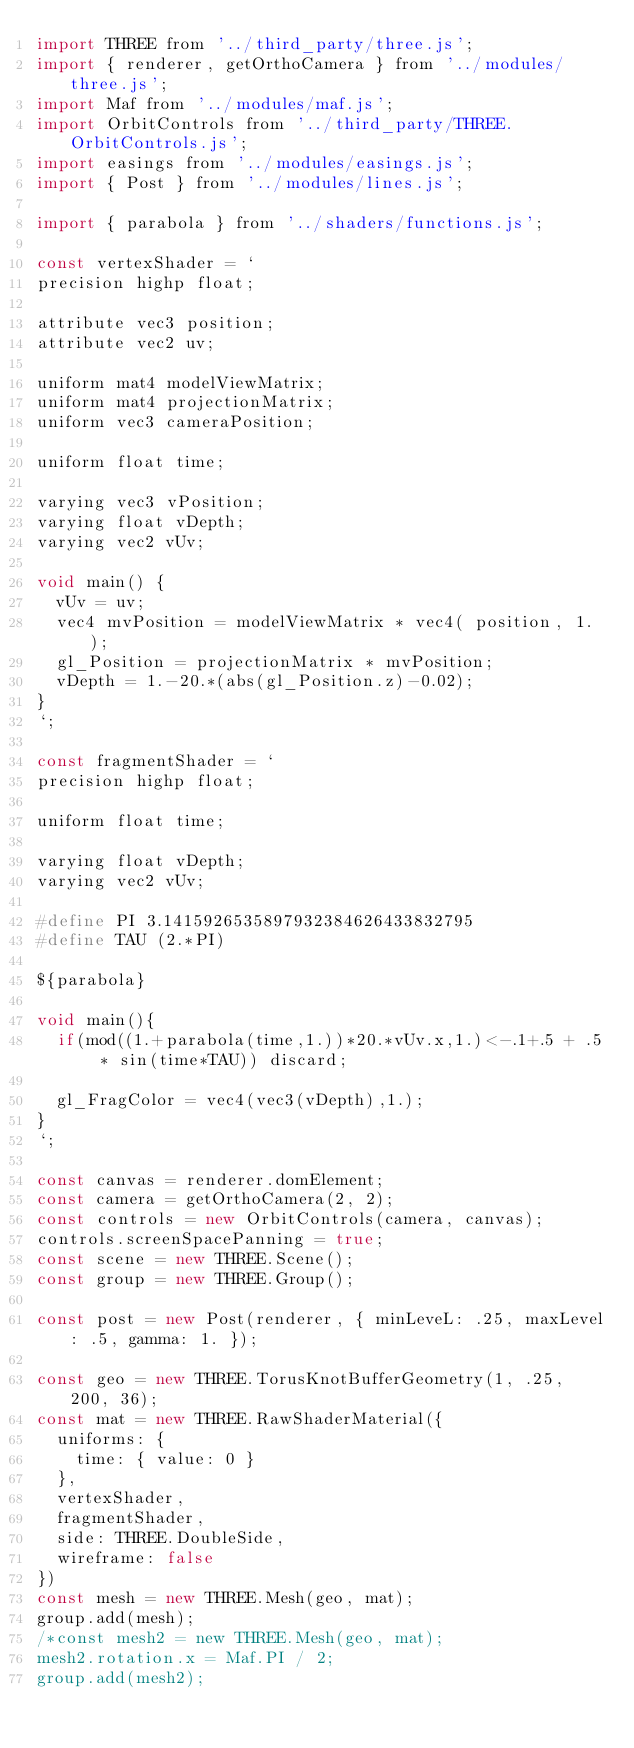Convert code to text. <code><loc_0><loc_0><loc_500><loc_500><_JavaScript_>import THREE from '../third_party/three.js';
import { renderer, getOrthoCamera } from '../modules/three.js';
import Maf from '../modules/maf.js';
import OrbitControls from '../third_party/THREE.OrbitControls.js';
import easings from '../modules/easings.js';
import { Post } from '../modules/lines.js';

import { parabola } from '../shaders/functions.js';

const vertexShader = `
precision highp float;

attribute vec3 position;
attribute vec2 uv;

uniform mat4 modelViewMatrix;
uniform mat4 projectionMatrix;
uniform vec3 cameraPosition;

uniform float time;

varying vec3 vPosition;
varying float vDepth;
varying vec2 vUv;

void main() {
  vUv = uv;
  vec4 mvPosition = modelViewMatrix * vec4( position, 1. );
  gl_Position = projectionMatrix * mvPosition;
  vDepth = 1.-20.*(abs(gl_Position.z)-0.02);
}
`;

const fragmentShader = `
precision highp float;

uniform float time;

varying float vDepth;
varying vec2 vUv;

#define PI 3.1415926535897932384626433832795
#define TAU (2.*PI)

${parabola}

void main(){
  if(mod((1.+parabola(time,1.))*20.*vUv.x,1.)<-.1+.5 + .5 * sin(time*TAU)) discard;

  gl_FragColor = vec4(vec3(vDepth),1.);
}
`;

const canvas = renderer.domElement;
const camera = getOrthoCamera(2, 2);
const controls = new OrbitControls(camera, canvas);
controls.screenSpacePanning = true;
const scene = new THREE.Scene();
const group = new THREE.Group();

const post = new Post(renderer, { minLeveL: .25, maxLevel: .5, gamma: 1. });

const geo = new THREE.TorusKnotBufferGeometry(1, .25, 200, 36);
const mat = new THREE.RawShaderMaterial({
  uniforms: {
    time: { value: 0 }
  },
  vertexShader,
  fragmentShader,
  side: THREE.DoubleSide,
  wireframe: false
})
const mesh = new THREE.Mesh(geo, mat);
group.add(mesh);
/*const mesh2 = new THREE.Mesh(geo, mat);
mesh2.rotation.x = Maf.PI / 2;
group.add(mesh2);</code> 